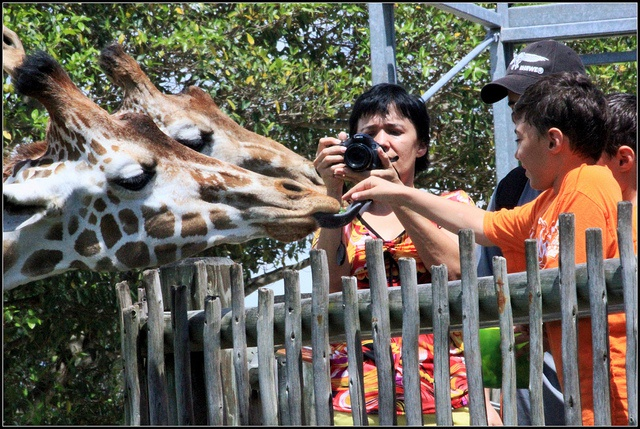Describe the objects in this image and their specific colors. I can see giraffe in black, gray, lightgray, and darkgray tones, people in black, orange, brown, and gray tones, people in black, maroon, gray, and lightgray tones, giraffe in black, lightgray, tan, and gray tones, and people in black, gray, and lavender tones in this image. 